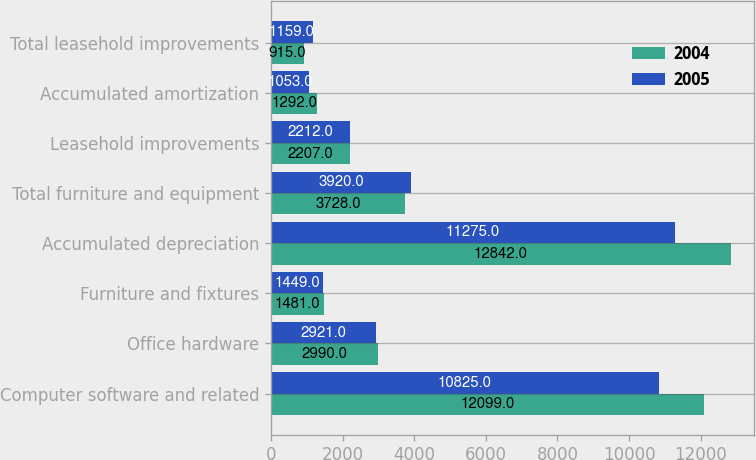Convert chart to OTSL. <chart><loc_0><loc_0><loc_500><loc_500><stacked_bar_chart><ecel><fcel>Computer software and related<fcel>Office hardware<fcel>Furniture and fixtures<fcel>Accumulated depreciation<fcel>Total furniture and equipment<fcel>Leasehold improvements<fcel>Accumulated amortization<fcel>Total leasehold improvements<nl><fcel>2004<fcel>12099<fcel>2990<fcel>1481<fcel>12842<fcel>3728<fcel>2207<fcel>1292<fcel>915<nl><fcel>2005<fcel>10825<fcel>2921<fcel>1449<fcel>11275<fcel>3920<fcel>2212<fcel>1053<fcel>1159<nl></chart> 